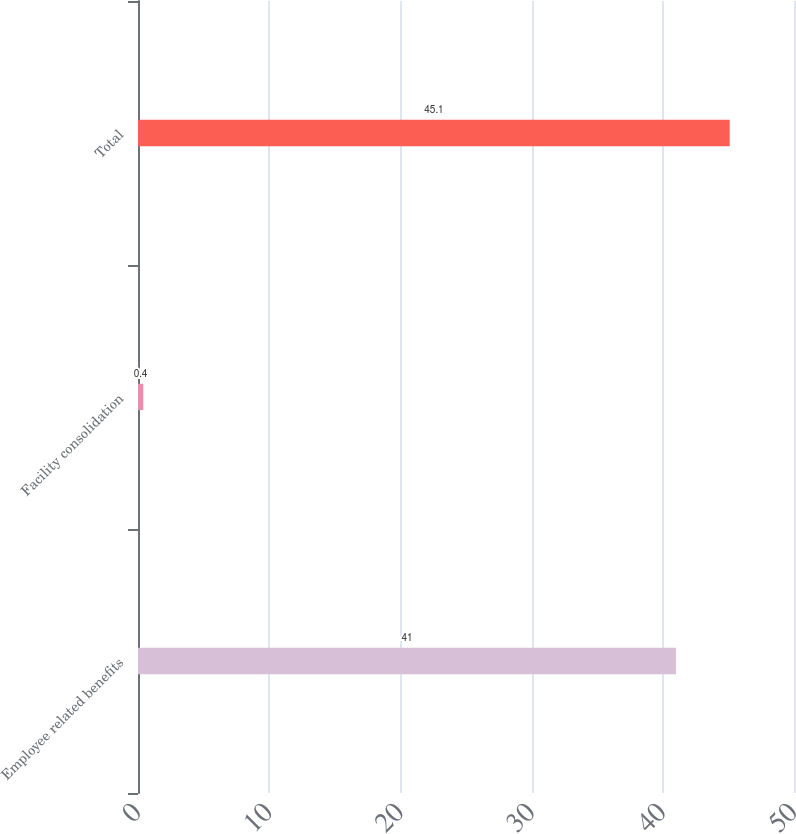Convert chart to OTSL. <chart><loc_0><loc_0><loc_500><loc_500><bar_chart><fcel>Employee related benefits<fcel>Facility consolidation<fcel>Total<nl><fcel>41<fcel>0.4<fcel>45.1<nl></chart> 